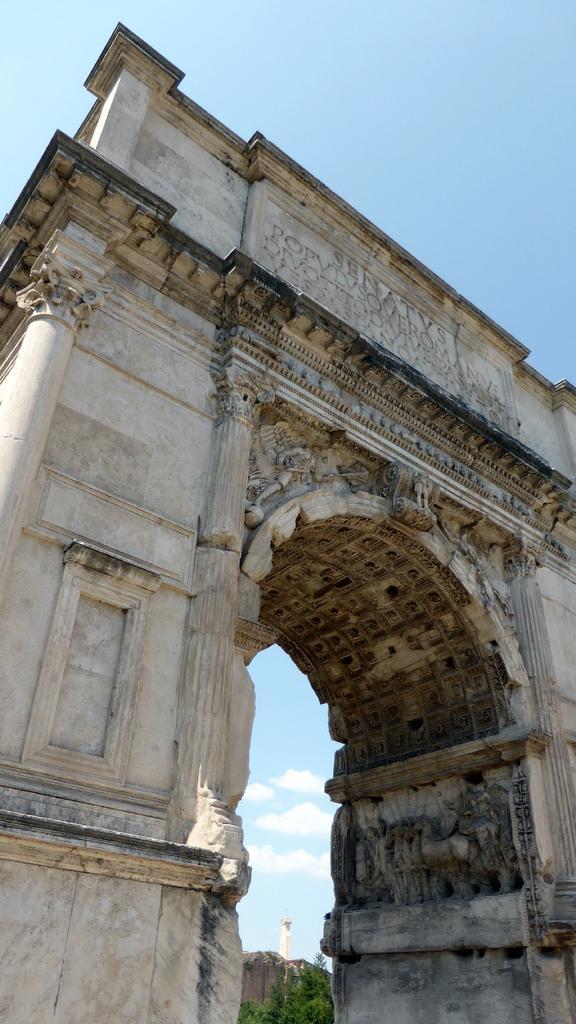Describe this image in one or two sentences. This picture is clicked outside. In the foreground we can see the wall on which we can see an arch and the text. In the background there is a sky and some other objects. 